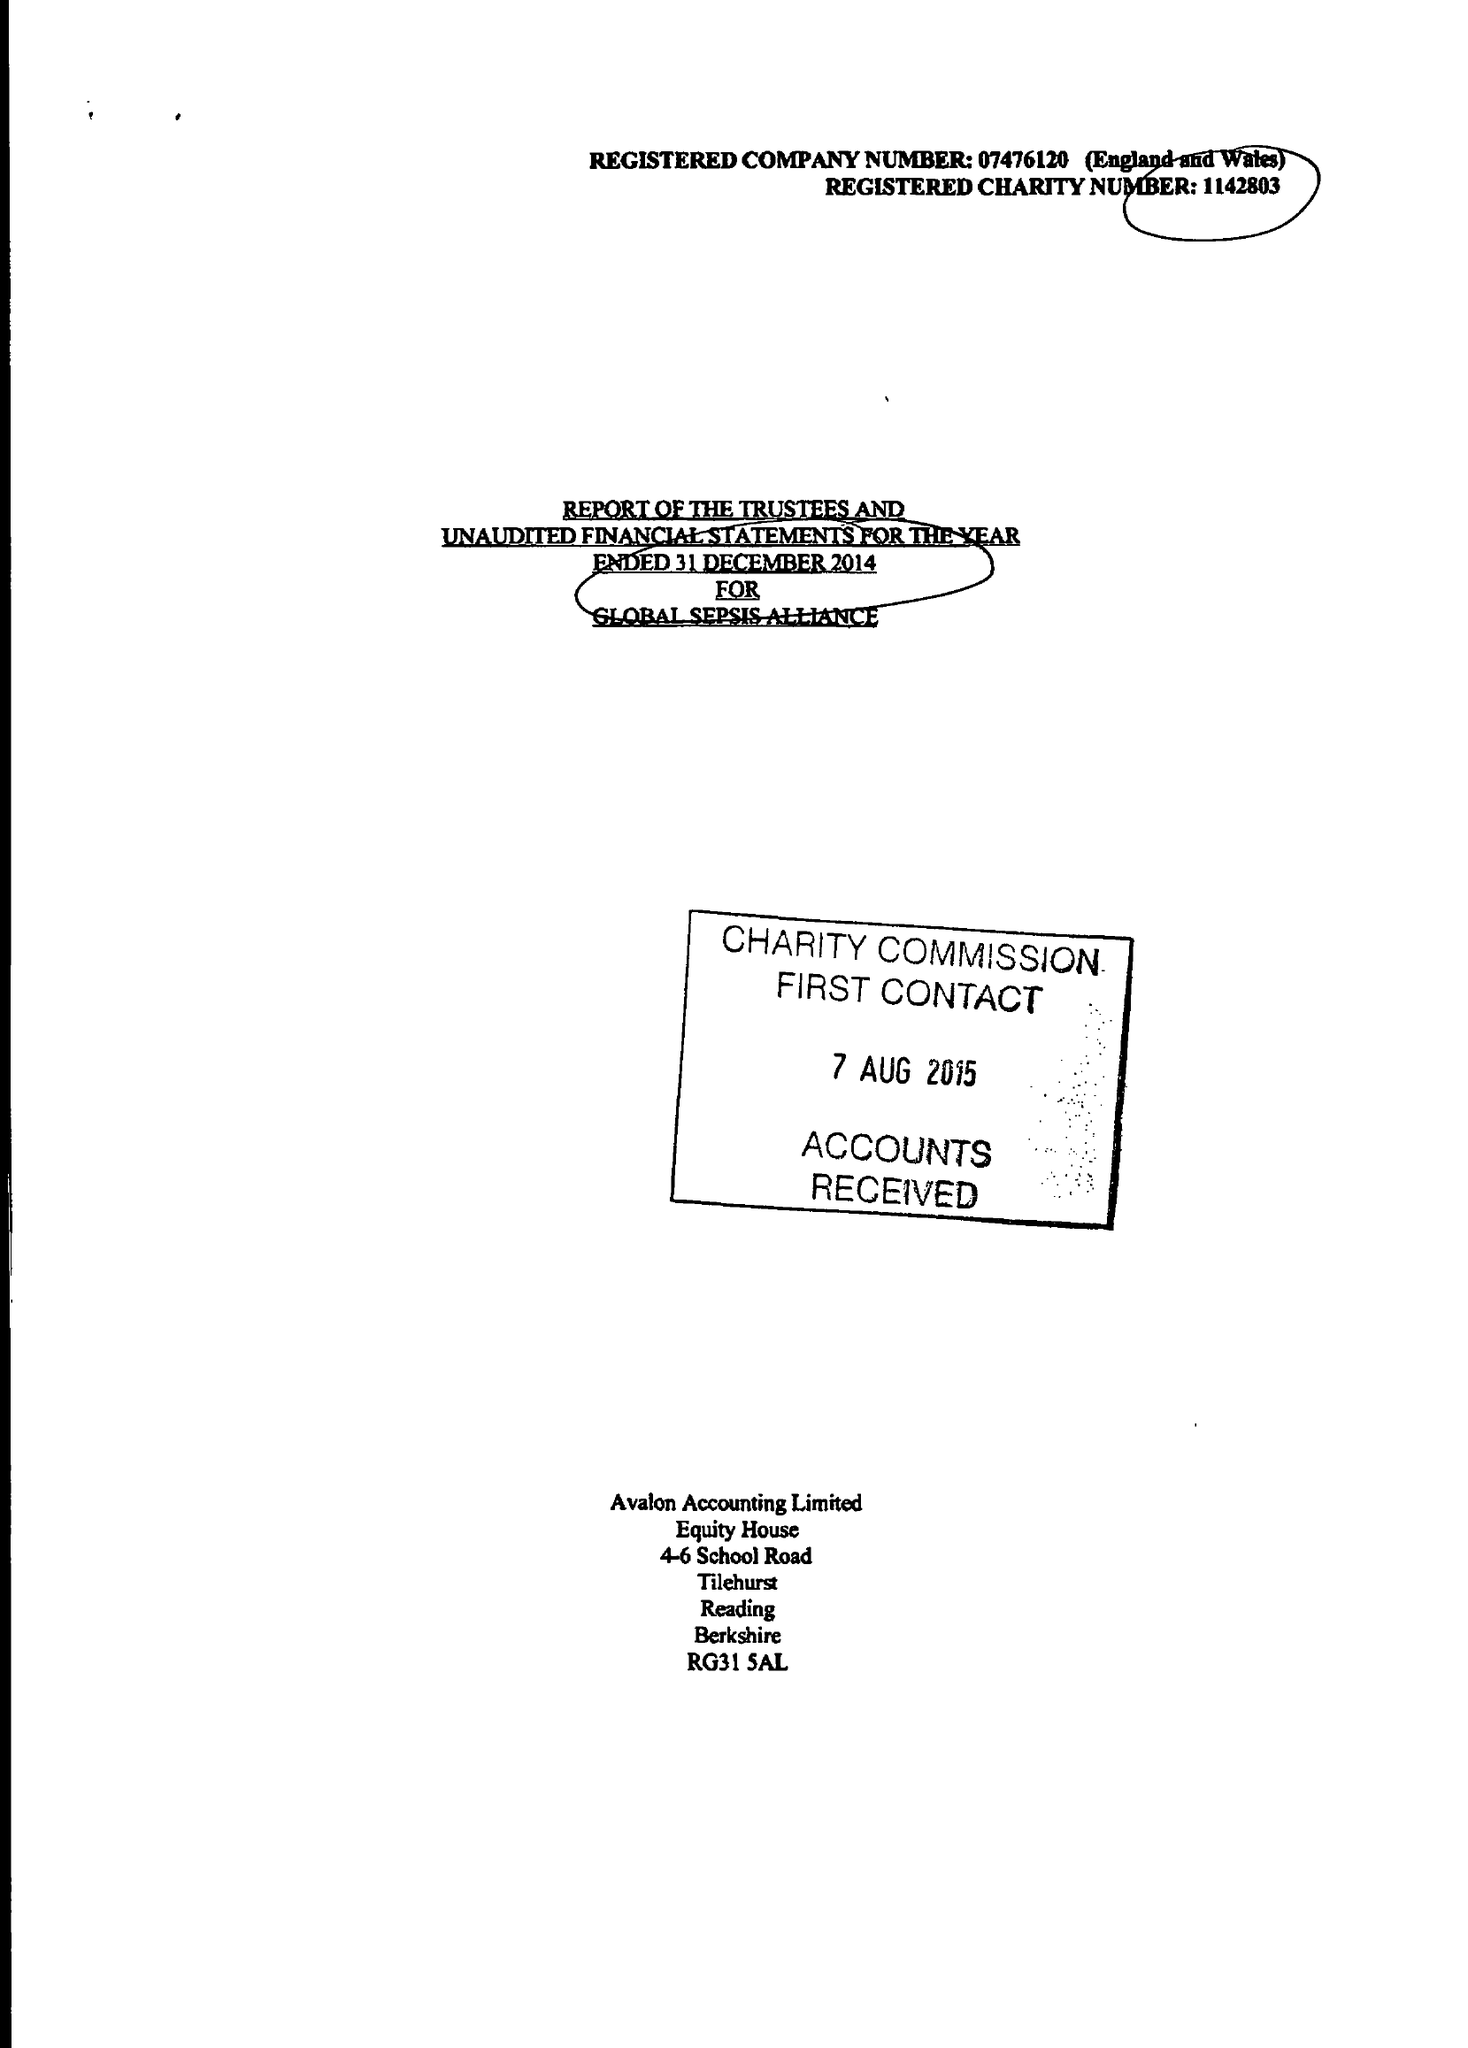What is the value for the spending_annually_in_british_pounds?
Answer the question using a single word or phrase. 53932.00 